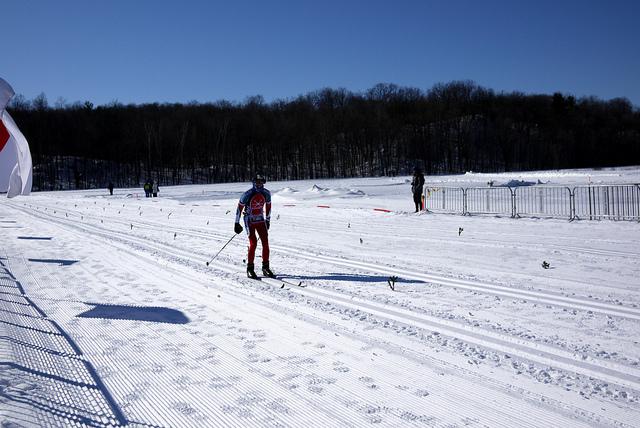How many skiers are in the photo?
Quick response, please. 1. How many people are there?
Be succinct. 5. Is this person cross country skiing?
Answer briefly. Yes. 